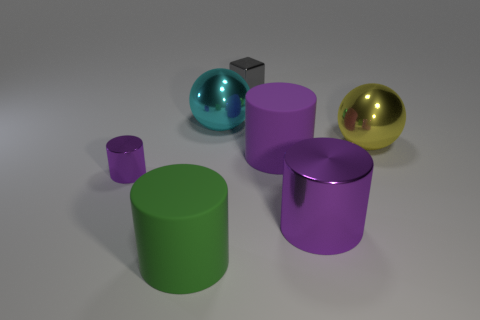There is a large yellow object that is made of the same material as the tiny cube; what is its shape?
Offer a terse response. Sphere. Do the yellow sphere and the cyan thing have the same material?
Provide a succinct answer. Yes. Are there fewer tiny cylinders that are behind the gray shiny cube than big shiny balls in front of the cyan metallic thing?
Provide a short and direct response. Yes. There is another rubber cylinder that is the same color as the small cylinder; what size is it?
Offer a terse response. Large. How many small purple things are behind the purple metallic cylinder that is left of the metallic sphere on the left side of the purple rubber cylinder?
Provide a succinct answer. 0. Does the metallic cube have the same color as the tiny metallic cylinder?
Provide a succinct answer. No. Are there any other blocks of the same color as the shiny cube?
Your response must be concise. No. There is a rubber cylinder that is the same size as the purple rubber thing; what color is it?
Ensure brevity in your answer.  Green. Is there a small gray thing of the same shape as the yellow shiny thing?
Keep it short and to the point. No. The shiny thing that is the same color as the tiny cylinder is what shape?
Offer a terse response. Cylinder. 